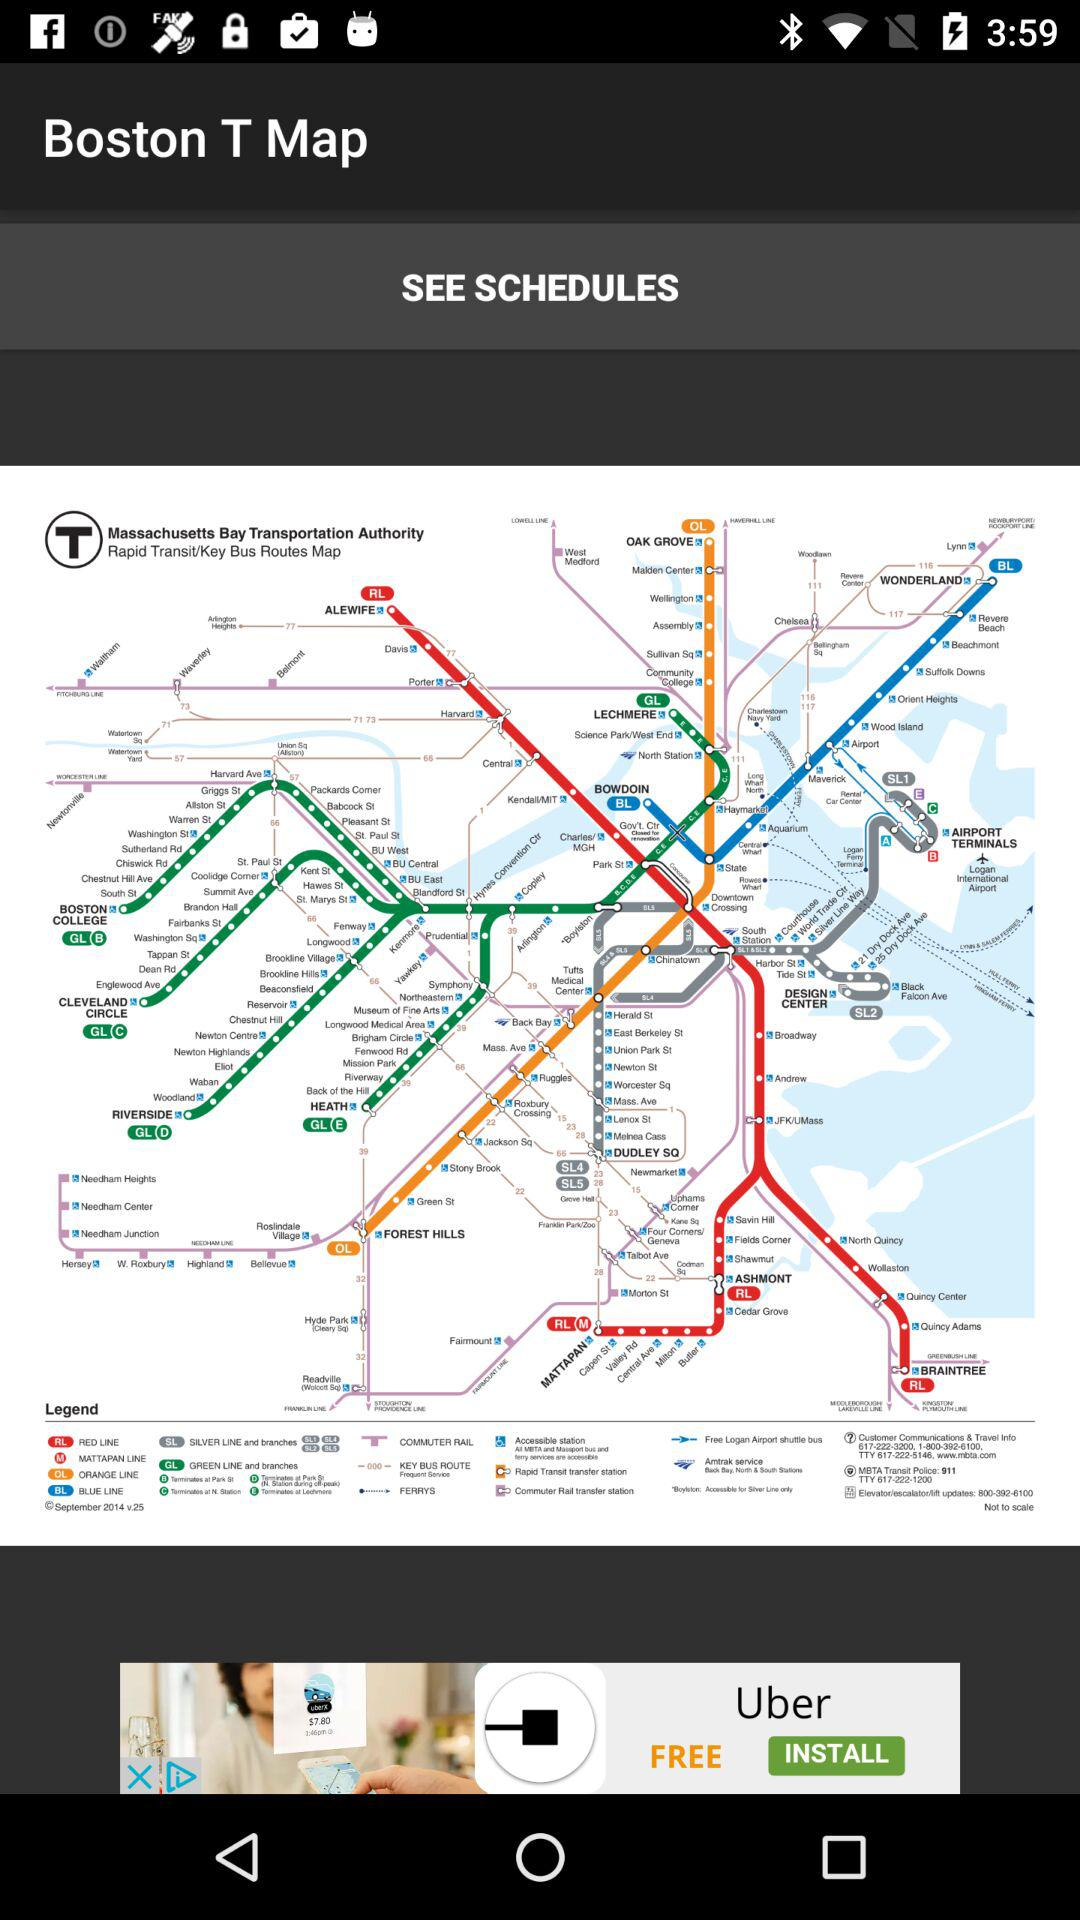What is the name of the application? The name of the application is "Boston T Map". 